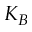<formula> <loc_0><loc_0><loc_500><loc_500>K _ { B }</formula> 